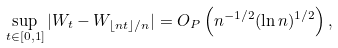<formula> <loc_0><loc_0><loc_500><loc_500>\sup _ { t \in [ 0 , 1 ] } | W _ { t } - W _ { \lfloor n t \rfloor / n } | = O _ { P } \left ( n ^ { - 1 / 2 } ( \ln n ) ^ { 1 / 2 } \right ) ,</formula> 